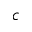<formula> <loc_0><loc_0><loc_500><loc_500>c</formula> 